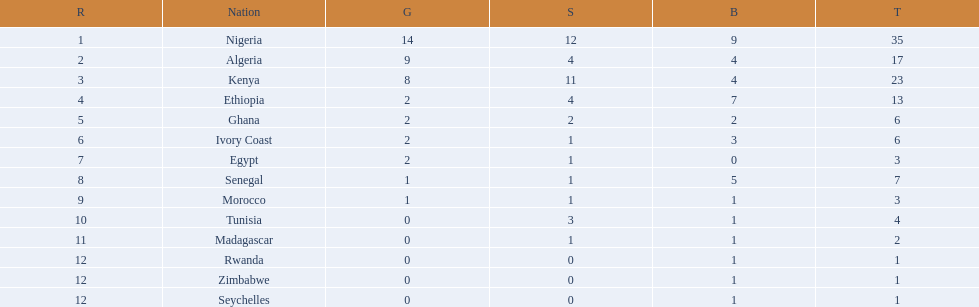What are all the nations? Nigeria, Algeria, Kenya, Ethiopia, Ghana, Ivory Coast, Egypt, Senegal, Morocco, Tunisia, Madagascar, Rwanda, Zimbabwe, Seychelles. How many bronze medals did they win? 9, 4, 4, 7, 2, 3, 0, 5, 1, 1, 1, 1, 1, 1. And which nation did not win one? Egypt. 